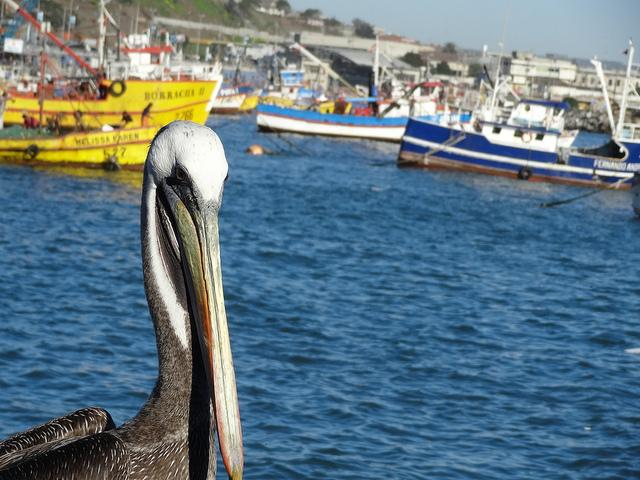On what continent was this photo most likely taken? Please explain your reasoning. south america. It was taken in south america. 